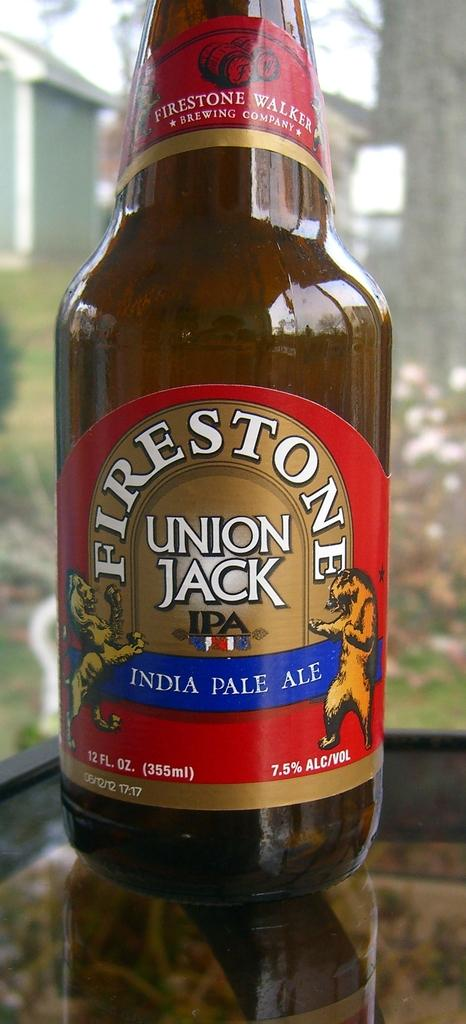Provide a one-sentence caption for the provided image. a bottle of firestone union jack india pale ale. 